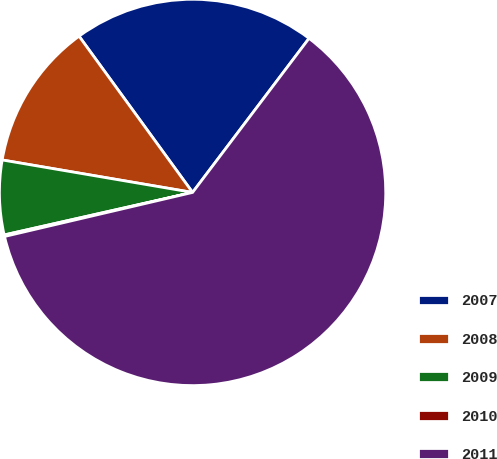Convert chart. <chart><loc_0><loc_0><loc_500><loc_500><pie_chart><fcel>2007<fcel>2008<fcel>2009<fcel>2010<fcel>2011<nl><fcel>20.3%<fcel>12.31%<fcel>6.22%<fcel>0.13%<fcel>61.03%<nl></chart> 